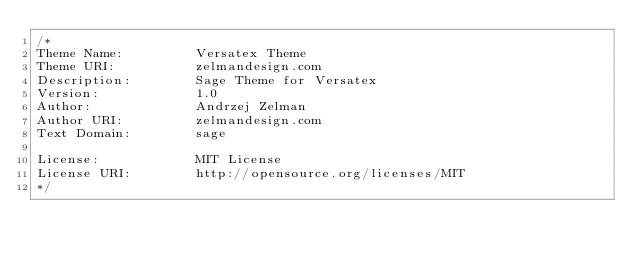<code> <loc_0><loc_0><loc_500><loc_500><_CSS_>/*
Theme Name:         Versatex Theme
Theme URI:          zelmandesign.com
Description:        Sage Theme for Versatex
Version:            1.0
Author:             Andrzej Zelman
Author URI:         zelmandesign.com
Text Domain:        sage

License:            MIT License
License URI:        http://opensource.org/licenses/MIT
*/
</code> 